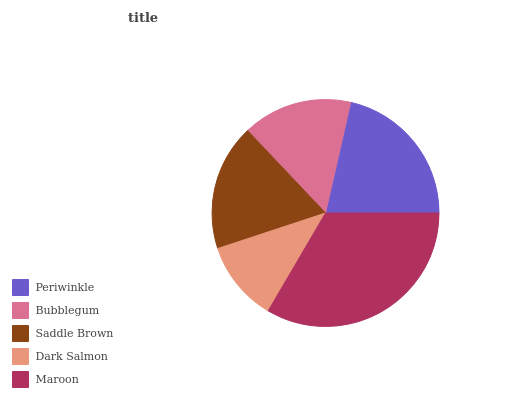Is Dark Salmon the minimum?
Answer yes or no. Yes. Is Maroon the maximum?
Answer yes or no. Yes. Is Bubblegum the minimum?
Answer yes or no. No. Is Bubblegum the maximum?
Answer yes or no. No. Is Periwinkle greater than Bubblegum?
Answer yes or no. Yes. Is Bubblegum less than Periwinkle?
Answer yes or no. Yes. Is Bubblegum greater than Periwinkle?
Answer yes or no. No. Is Periwinkle less than Bubblegum?
Answer yes or no. No. Is Saddle Brown the high median?
Answer yes or no. Yes. Is Saddle Brown the low median?
Answer yes or no. Yes. Is Maroon the high median?
Answer yes or no. No. Is Periwinkle the low median?
Answer yes or no. No. 